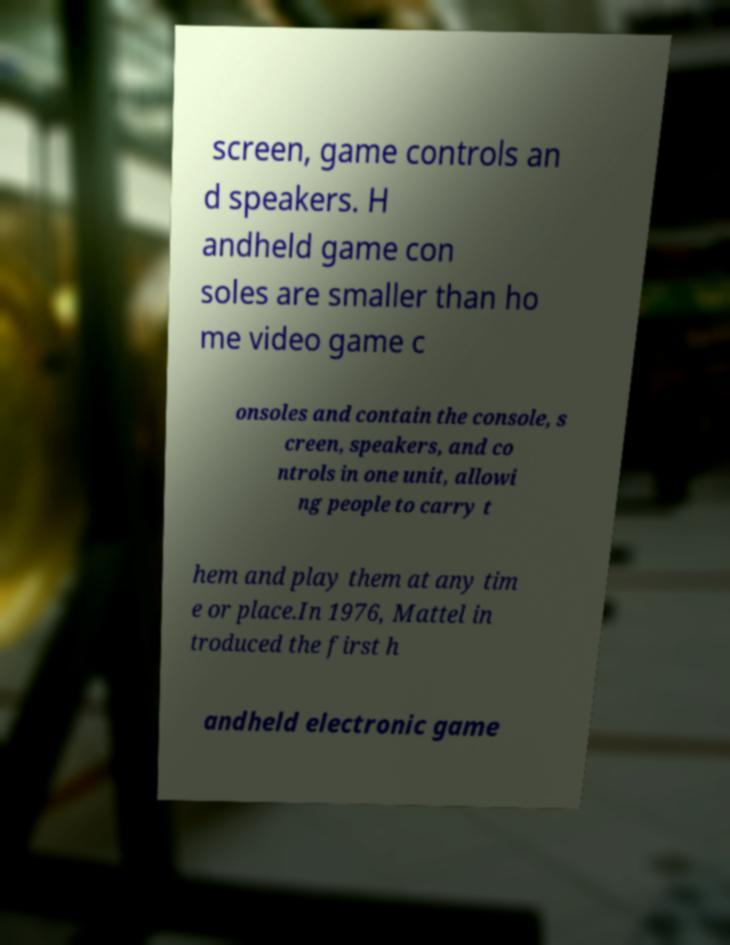For documentation purposes, I need the text within this image transcribed. Could you provide that? screen, game controls an d speakers. H andheld game con soles are smaller than ho me video game c onsoles and contain the console, s creen, speakers, and co ntrols in one unit, allowi ng people to carry t hem and play them at any tim e or place.In 1976, Mattel in troduced the first h andheld electronic game 